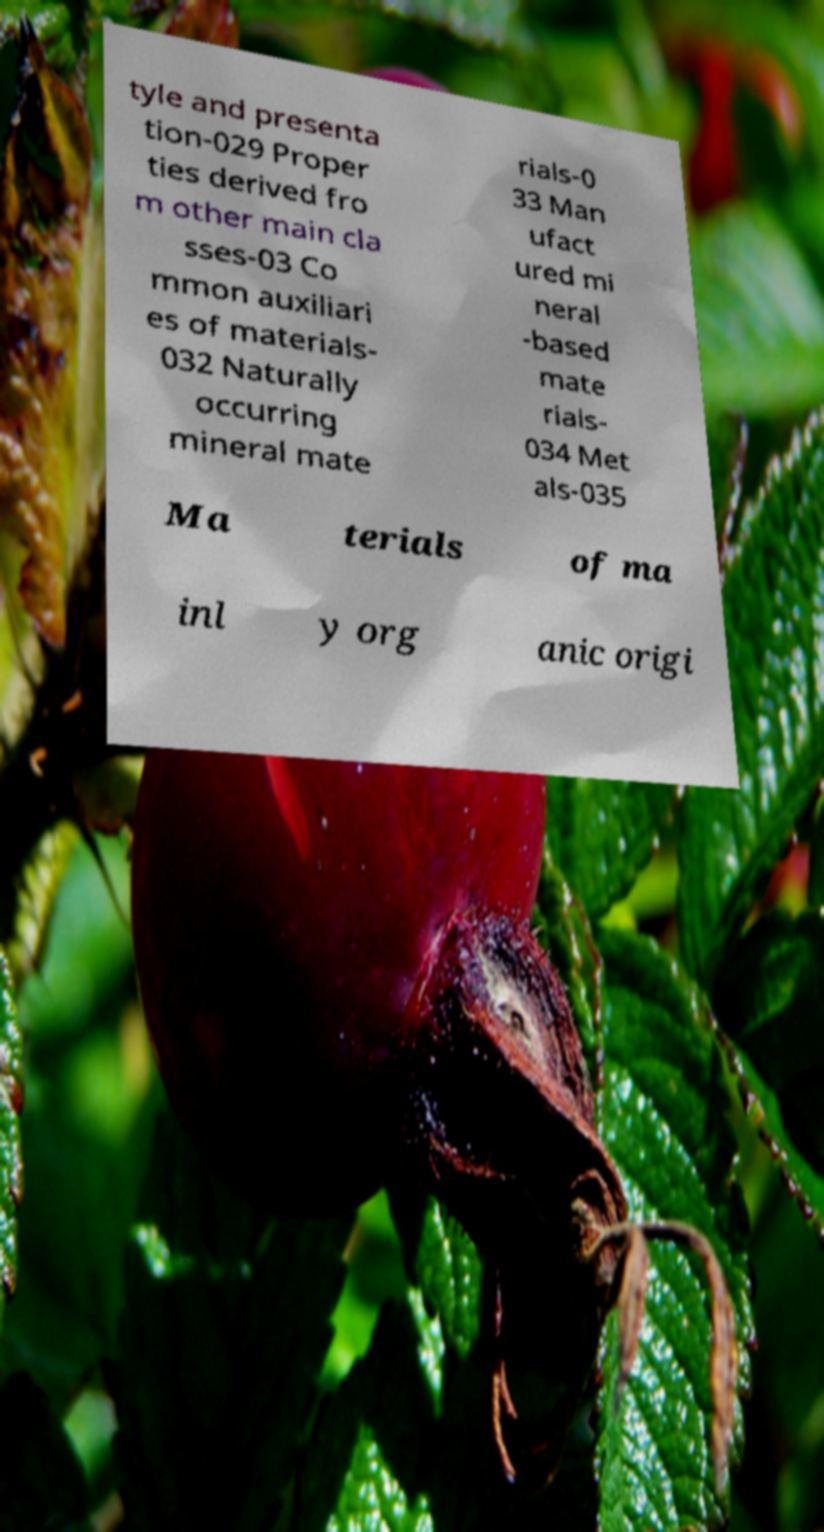I need the written content from this picture converted into text. Can you do that? tyle and presenta tion-029 Proper ties derived fro m other main cla sses-03 Co mmon auxiliari es of materials- 032 Naturally occurring mineral mate rials-0 33 Man ufact ured mi neral -based mate rials- 034 Met als-035 Ma terials of ma inl y org anic origi 